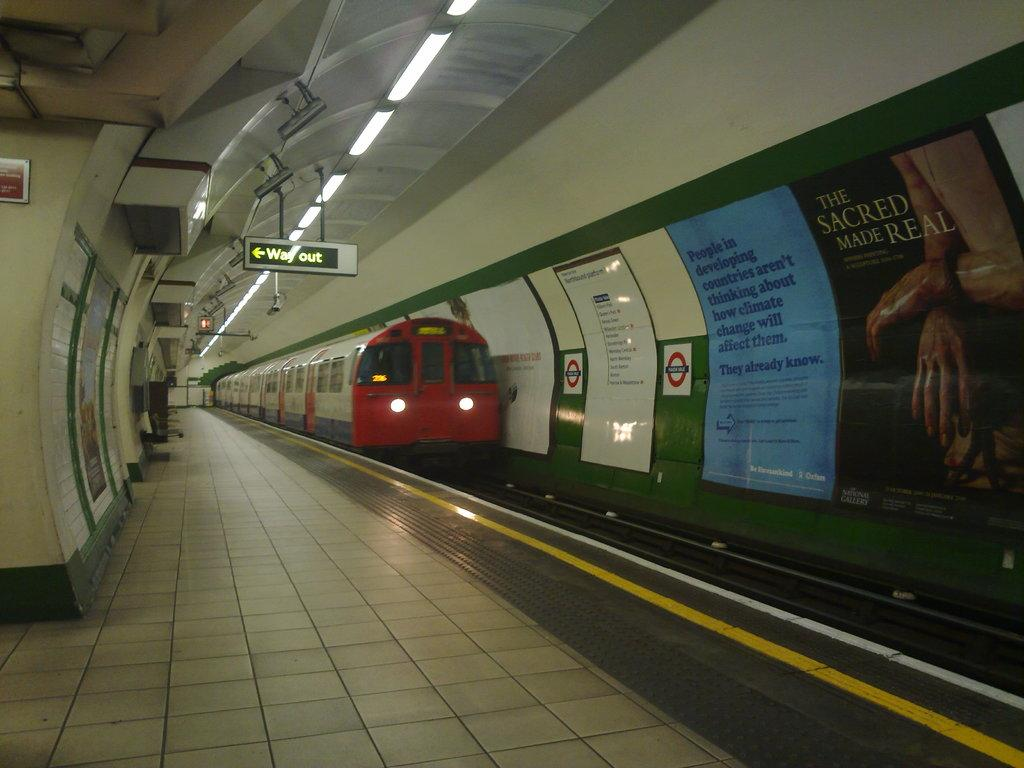What can be seen on the track in the image? There is a train on the track in the image. What type of area is depicted in the image? This is a platform, as indicated by the presence of a train and the boards visible. What other objects can be seen on the platform? There are lights and posters visible on the platform. What structures surround the platform? There is a wall and a roof visible in the image. Can you see a glove being used by someone on the platform in the image? There is no glove visible in the image, nor is there any indication of someone using a glove on the platform. 